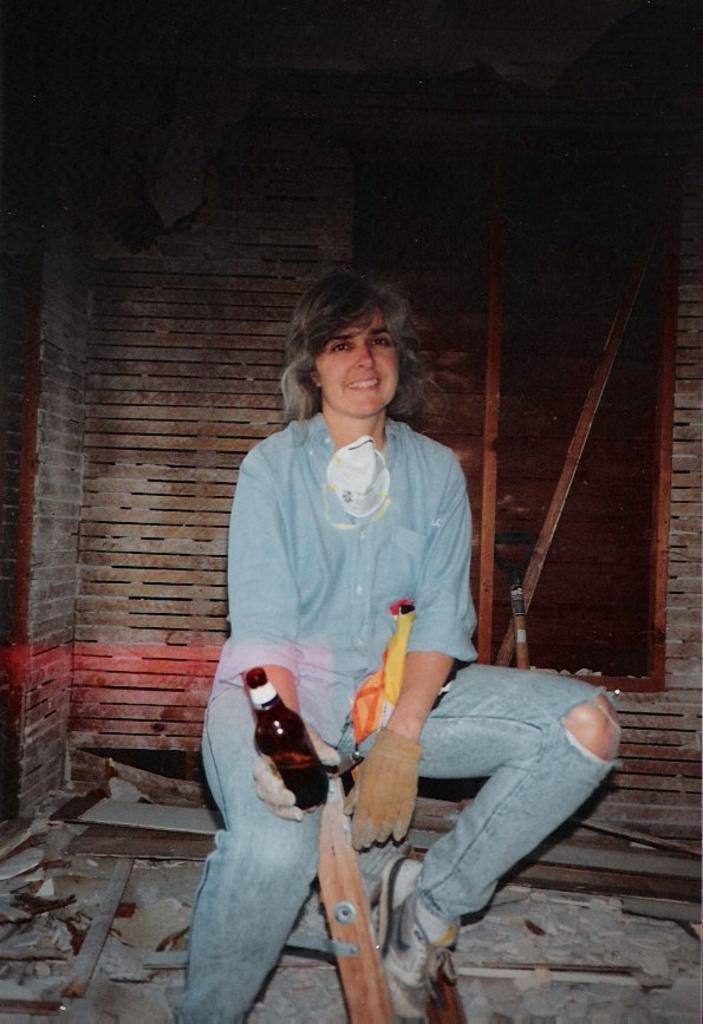Can you describe this image briefly? In this image I can see a woman holding a glass. At the back side there is a wall. 